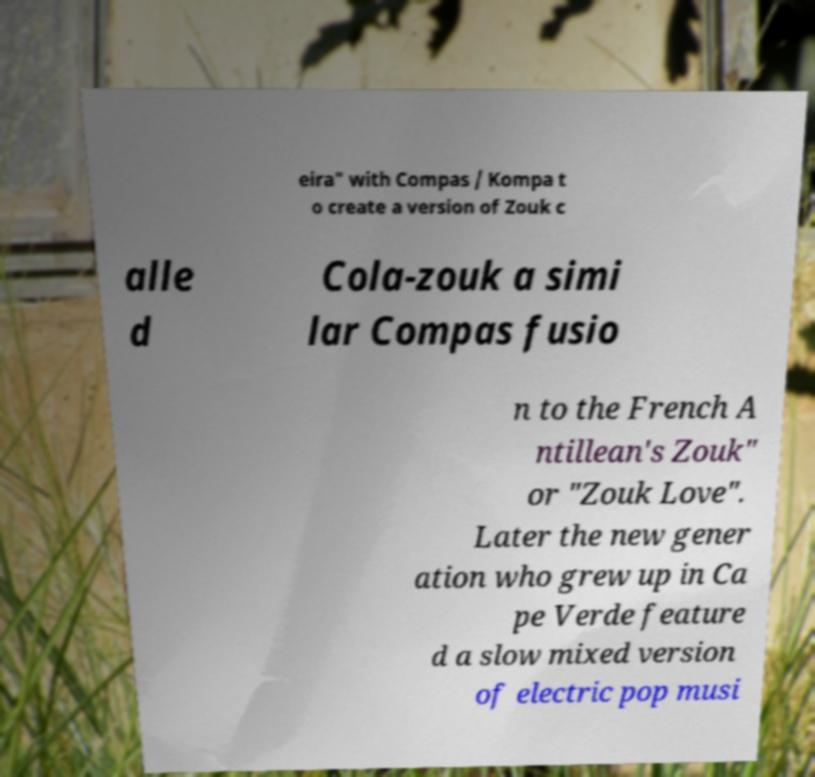Can you accurately transcribe the text from the provided image for me? eira" with Compas / Kompa t o create a version of Zouk c alle d Cola-zouk a simi lar Compas fusio n to the French A ntillean's Zouk" or "Zouk Love". Later the new gener ation who grew up in Ca pe Verde feature d a slow mixed version of electric pop musi 